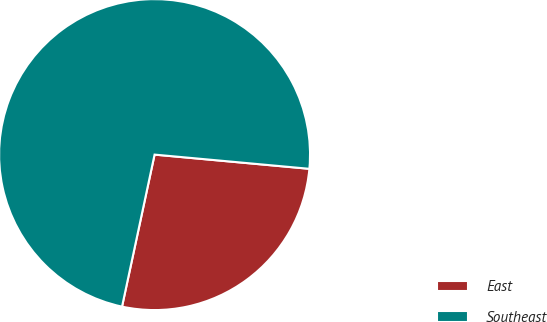Convert chart to OTSL. <chart><loc_0><loc_0><loc_500><loc_500><pie_chart><fcel>East<fcel>Southeast<nl><fcel>26.9%<fcel>73.1%<nl></chart> 